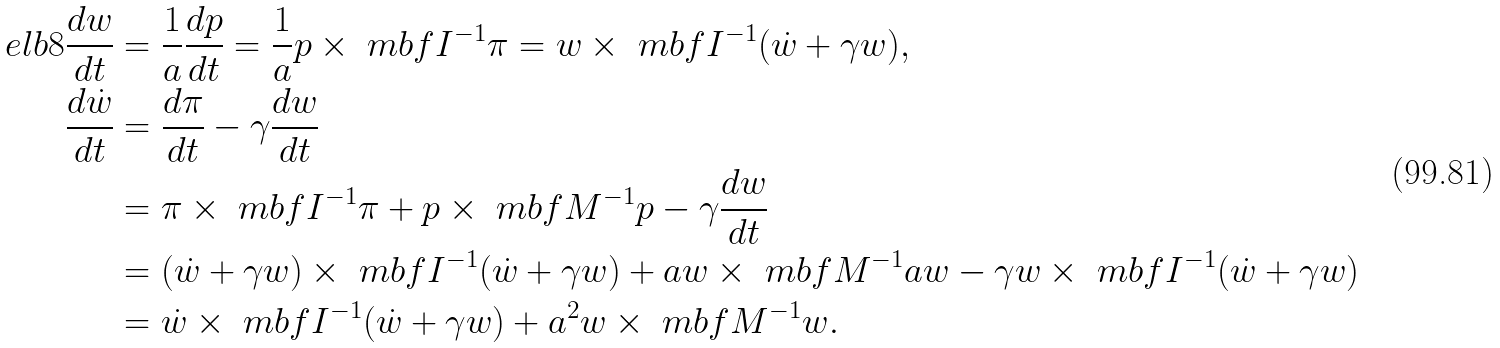<formula> <loc_0><loc_0><loc_500><loc_500>\ e l b { 8 } \frac { d w } { d t } & = \frac { 1 } { a } \frac { d p } { d t } = \frac { 1 } { a } p \times \ m b f I ^ { - 1 } \pi = w \times \ m b f I ^ { - 1 } ( \dot { w } + \gamma w ) , \\ \frac { d \dot { w } } { d t } & = \frac { d \pi } { d t } - \gamma \frac { d w } { d t } \\ & = \pi \times \ m b f I ^ { - 1 } \pi + p \times \ m b f M ^ { - 1 } p - \gamma \frac { d w } { d t } \\ & = ( \dot { w } + \gamma w ) \times \ m b f I ^ { - 1 } ( \dot { w } + \gamma w ) + a w \times \ m b f M ^ { - 1 } a w - \gamma w \times \ m b f I ^ { - 1 } ( \dot { w } + \gamma w ) \\ & = \dot { w } \times \ m b f I ^ { - 1 } ( \dot { w } + \gamma w ) + a ^ { 2 } w \times \ m b f M ^ { - 1 } w .</formula> 